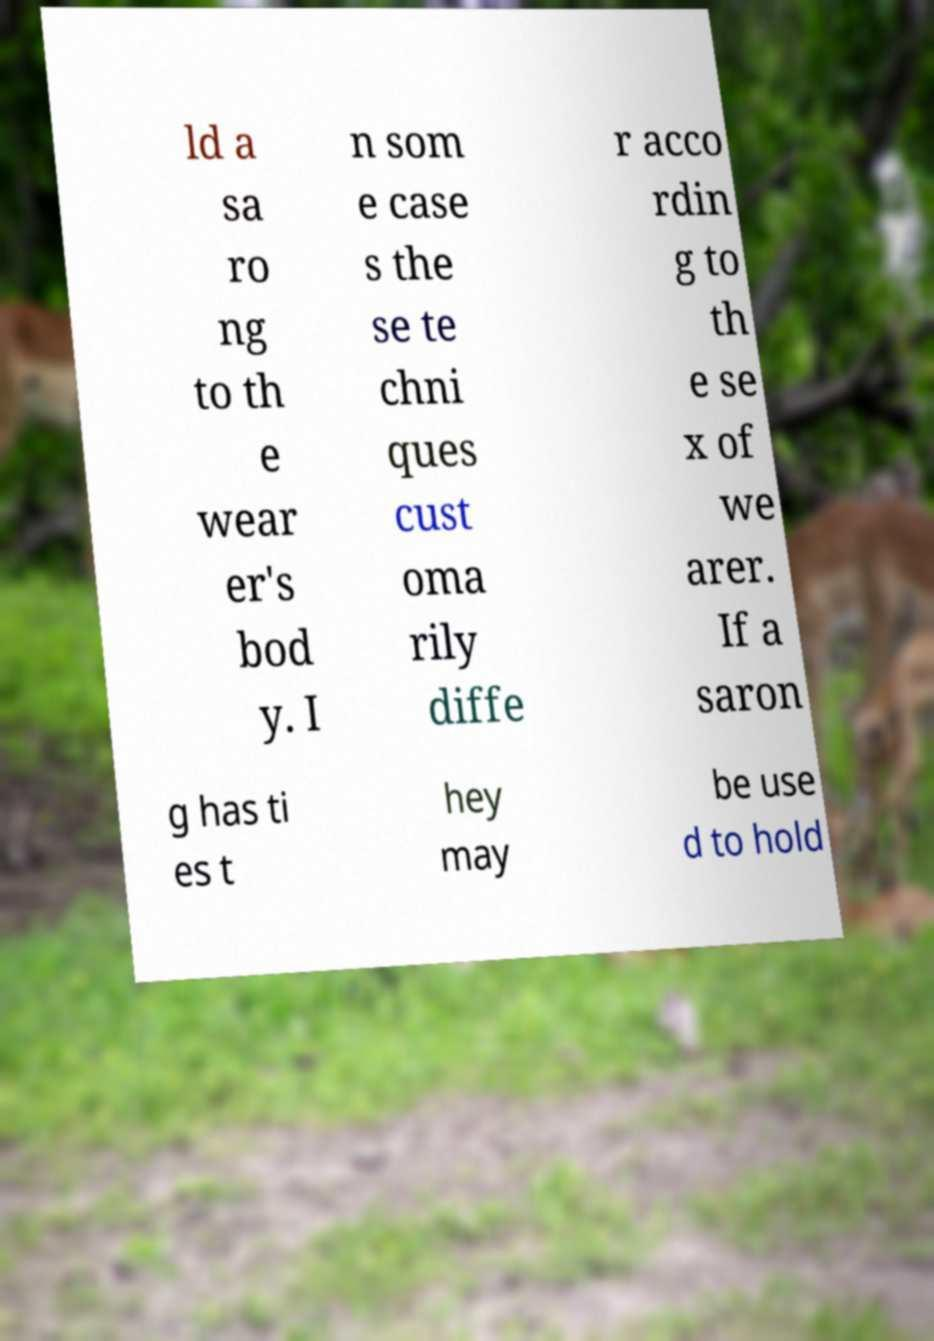Please read and relay the text visible in this image. What does it say? ld a sa ro ng to th e wear er's bod y. I n som e case s the se te chni ques cust oma rily diffe r acco rdin g to th e se x of we arer. If a saron g has ti es t hey may be use d to hold 